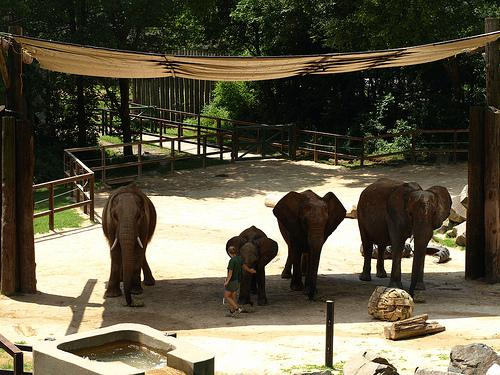Question: where are the elephants?
Choices:
A. In the jungle.
B. Artificial habitat.
C. In a grassland.
D. In a field.
Answer with the letter. Answer: B Question: what type of animals are shown?
Choices:
A. Moose.
B. Lions.
C. Elephants.
D. Giraffes.
Answer with the letter. Answer: C Question: what are the elephants standing on?
Choices:
A. Concrete.
B. Dirt.
C. Grass.
D. Stones.
Answer with the letter. Answer: B 